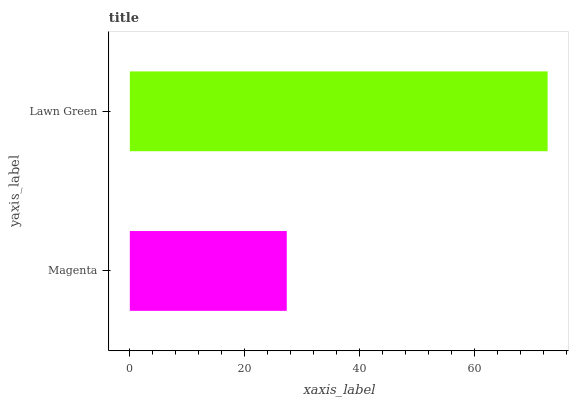Is Magenta the minimum?
Answer yes or no. Yes. Is Lawn Green the maximum?
Answer yes or no. Yes. Is Lawn Green the minimum?
Answer yes or no. No. Is Lawn Green greater than Magenta?
Answer yes or no. Yes. Is Magenta less than Lawn Green?
Answer yes or no. Yes. Is Magenta greater than Lawn Green?
Answer yes or no. No. Is Lawn Green less than Magenta?
Answer yes or no. No. Is Lawn Green the high median?
Answer yes or no. Yes. Is Magenta the low median?
Answer yes or no. Yes. Is Magenta the high median?
Answer yes or no. No. Is Lawn Green the low median?
Answer yes or no. No. 